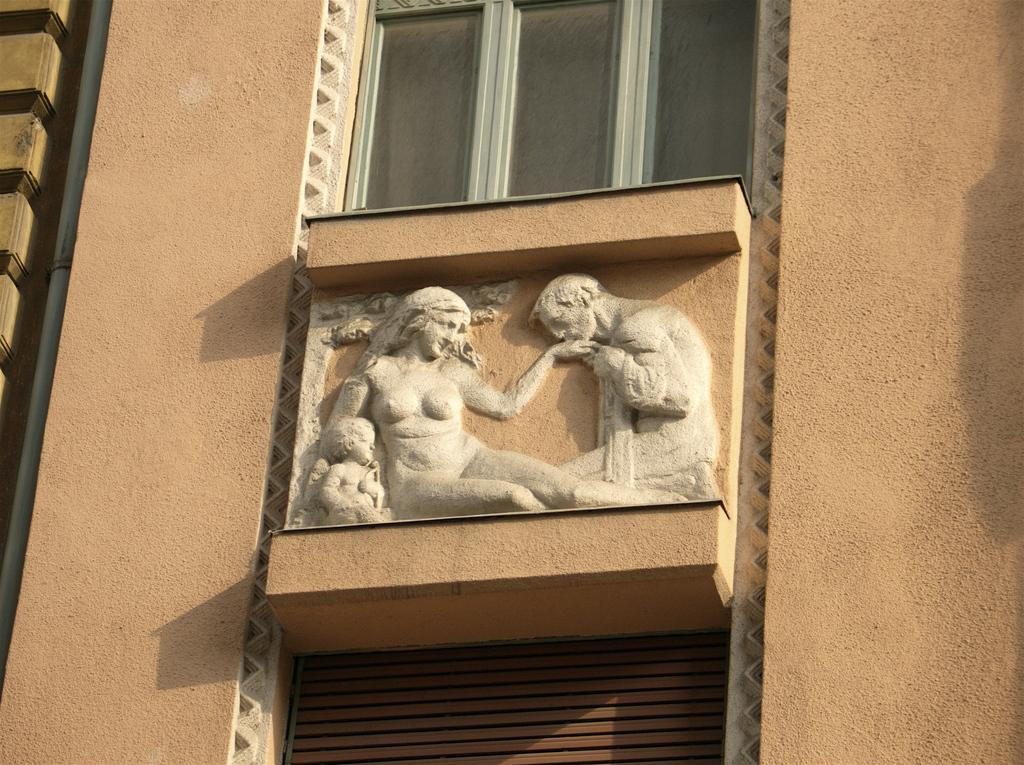What type of artwork can be seen in the image? There are sculptures in the image. What is the background of the image? There is a wall in the image. Can you describe a specific feature on the wall? There is a pipe on the wall on the left side. What architectural elements are present in the image? There are windows in the image. What else can be seen in the image besides the sculptures and wall? There are objects in the image. What type of plants can be seen growing near the sculptures in the image? There are no plants visible in the image; it only features sculptures, a wall, a pipe, windows, and objects. 